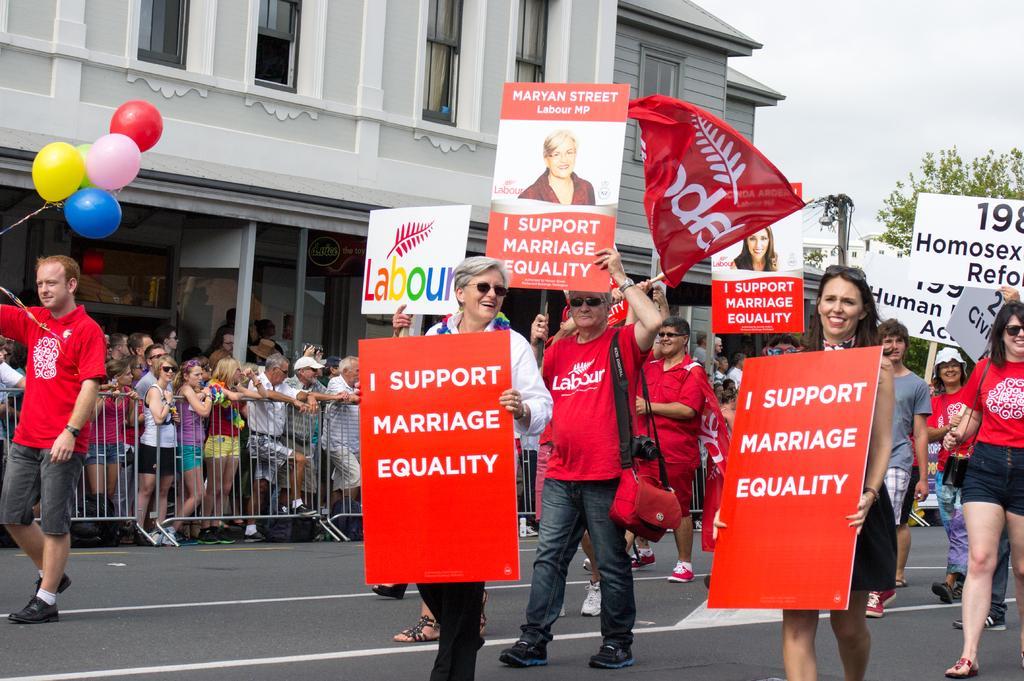Describe this image in one or two sentences. In this image we can see a group of persons walking and there are holding placards with some text on it. Behind the persons we can see a building, barrier and a group of persons. On the top right, we can see the sky and a tree. On the left side, we can see a person holding balloons. 